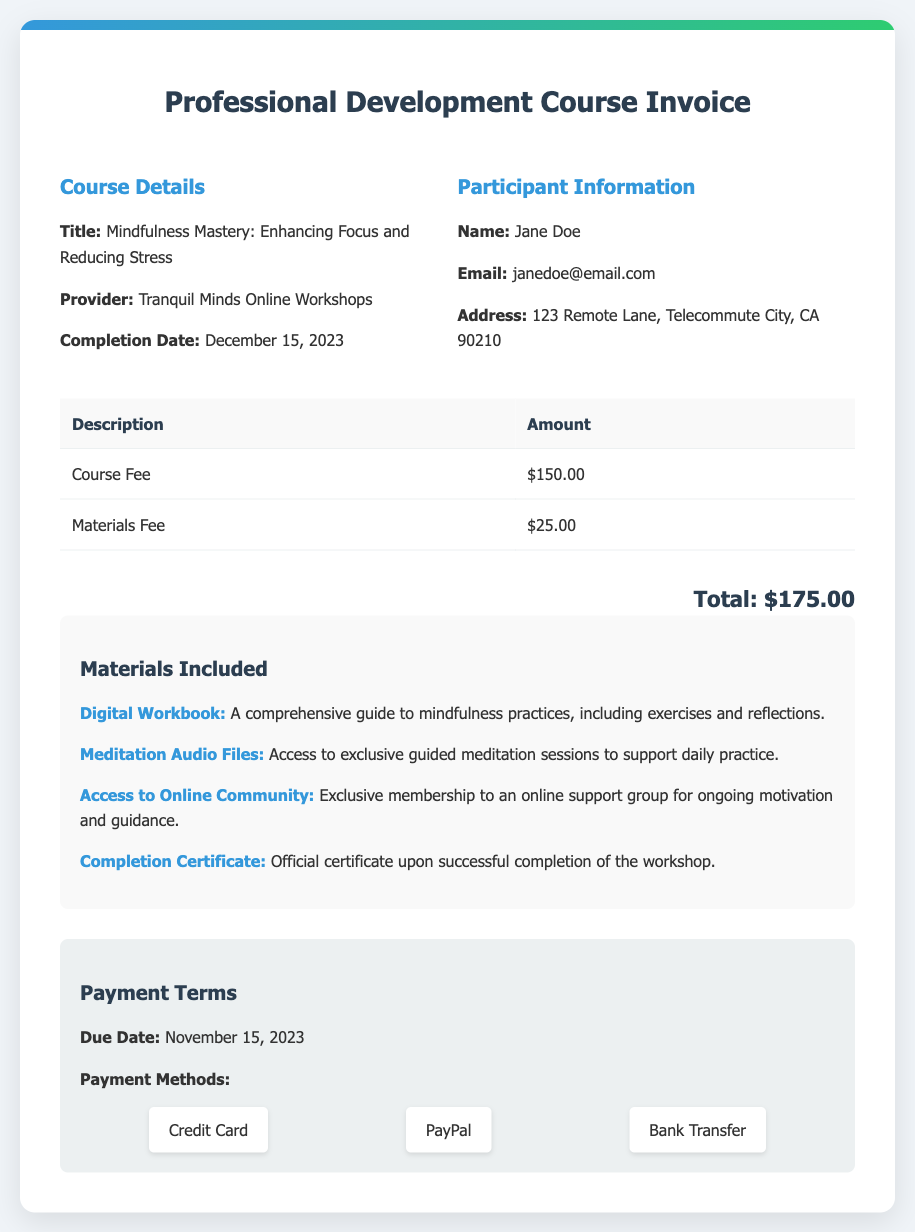What is the title of the course? The title of the course is presented in the document under Course Details.
Answer: Mindfulness Mastery: Enhancing Focus and Reducing Stress Who is the provider of the workshop? The provider's name is mentioned in the Course Details section.
Answer: Tranquil Minds Online Workshops What is the total amount due for the course? The total amount is calculated by adding the Course Fee and Materials Fee shown in the invoice.
Answer: $175.00 What is the completion date of the course? The completion date is specified in the Course Details section of the document.
Answer: December 15, 2023 What is included in the materials? The materials list provides details on the included items, like the Digital Workbook.
Answer: Digital Workbook, Meditation Audio Files, Access to Online Community, Completion Certificate When is the payment due? The due date for payment is mentioned in the Payment Terms section.
Answer: November 15, 2023 List one payment method accepted. Various payment methods are noted in the Payment Terms section.
Answer: Credit Card How much is the materials fee? The materials fee can be found in the table of charges in the document.
Answer: $25.00 